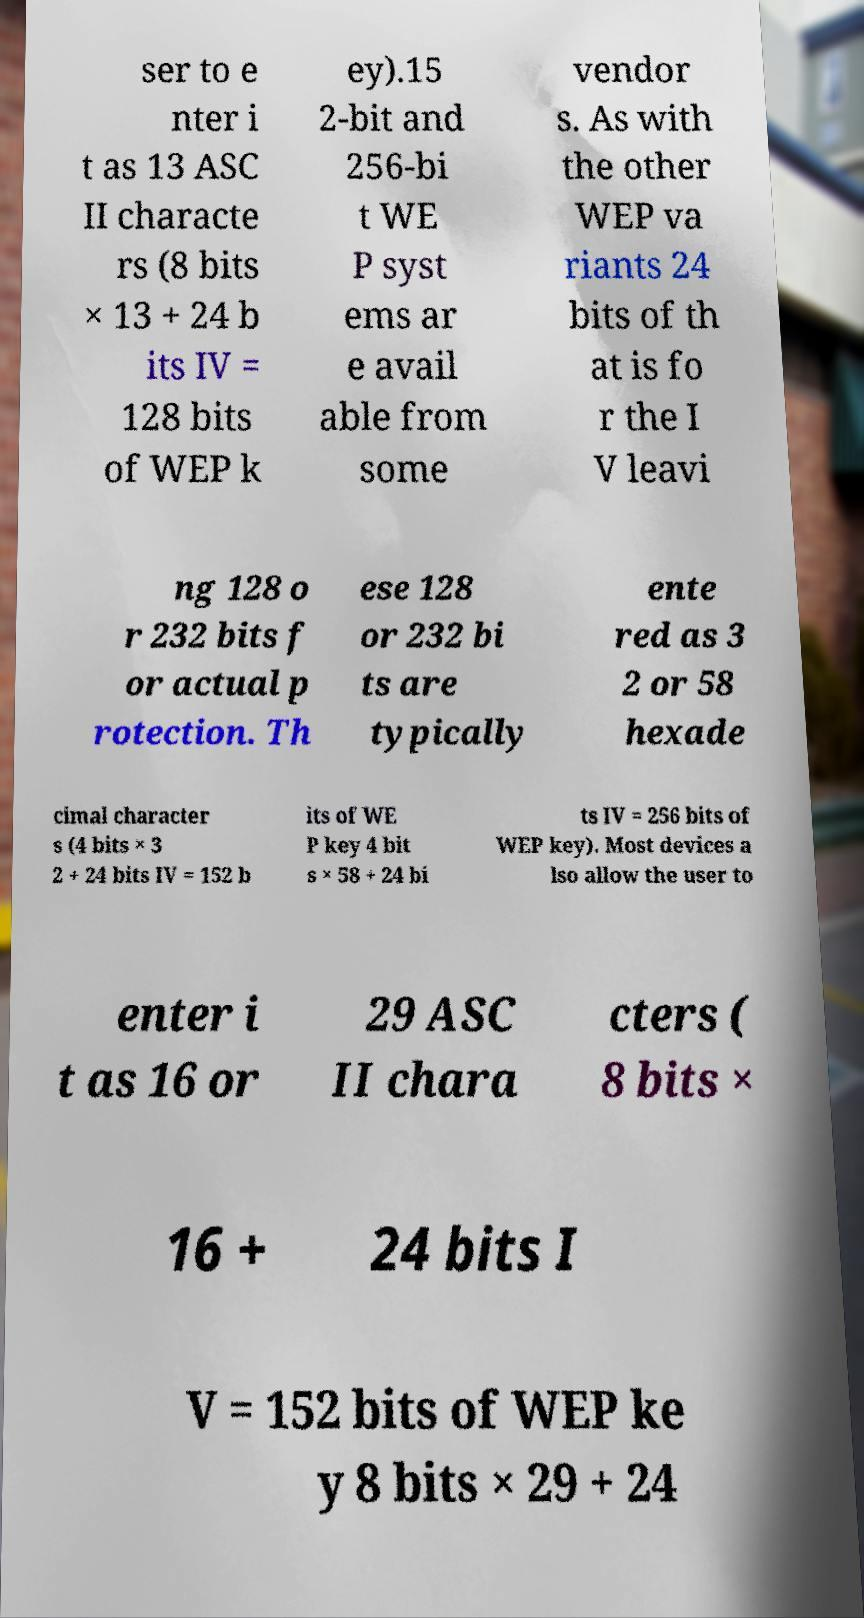Please read and relay the text visible in this image. What does it say? ser to e nter i t as 13 ASC II characte rs (8 bits × 13 + 24 b its IV = 128 bits of WEP k ey).15 2-bit and 256-bi t WE P syst ems ar e avail able from some vendor s. As with the other WEP va riants 24 bits of th at is fo r the I V leavi ng 128 o r 232 bits f or actual p rotection. Th ese 128 or 232 bi ts are typically ente red as 3 2 or 58 hexade cimal character s (4 bits × 3 2 + 24 bits IV = 152 b its of WE P key 4 bit s × 58 + 24 bi ts IV = 256 bits of WEP key). Most devices a lso allow the user to enter i t as 16 or 29 ASC II chara cters ( 8 bits × 16 + 24 bits I V = 152 bits of WEP ke y 8 bits × 29 + 24 